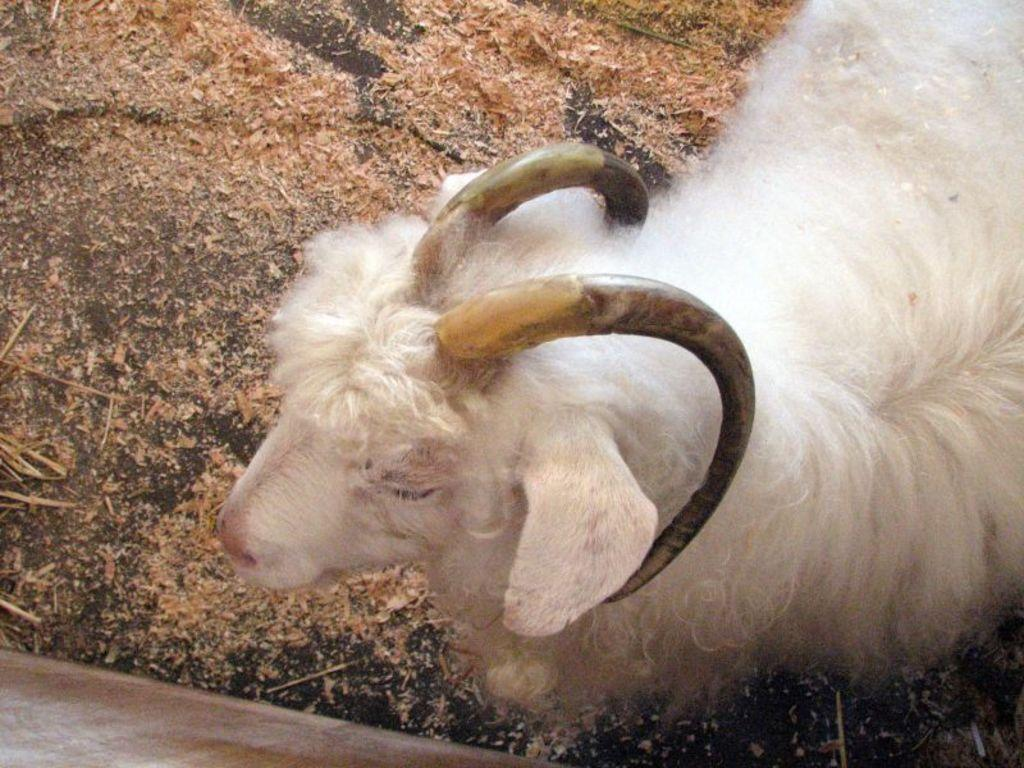What type of animal is present in the image? There is a white color sheep in the image. How many frogs are sitting on the shelf in the image? There are no frogs or shelves present in the image; it features a white color sheep. 